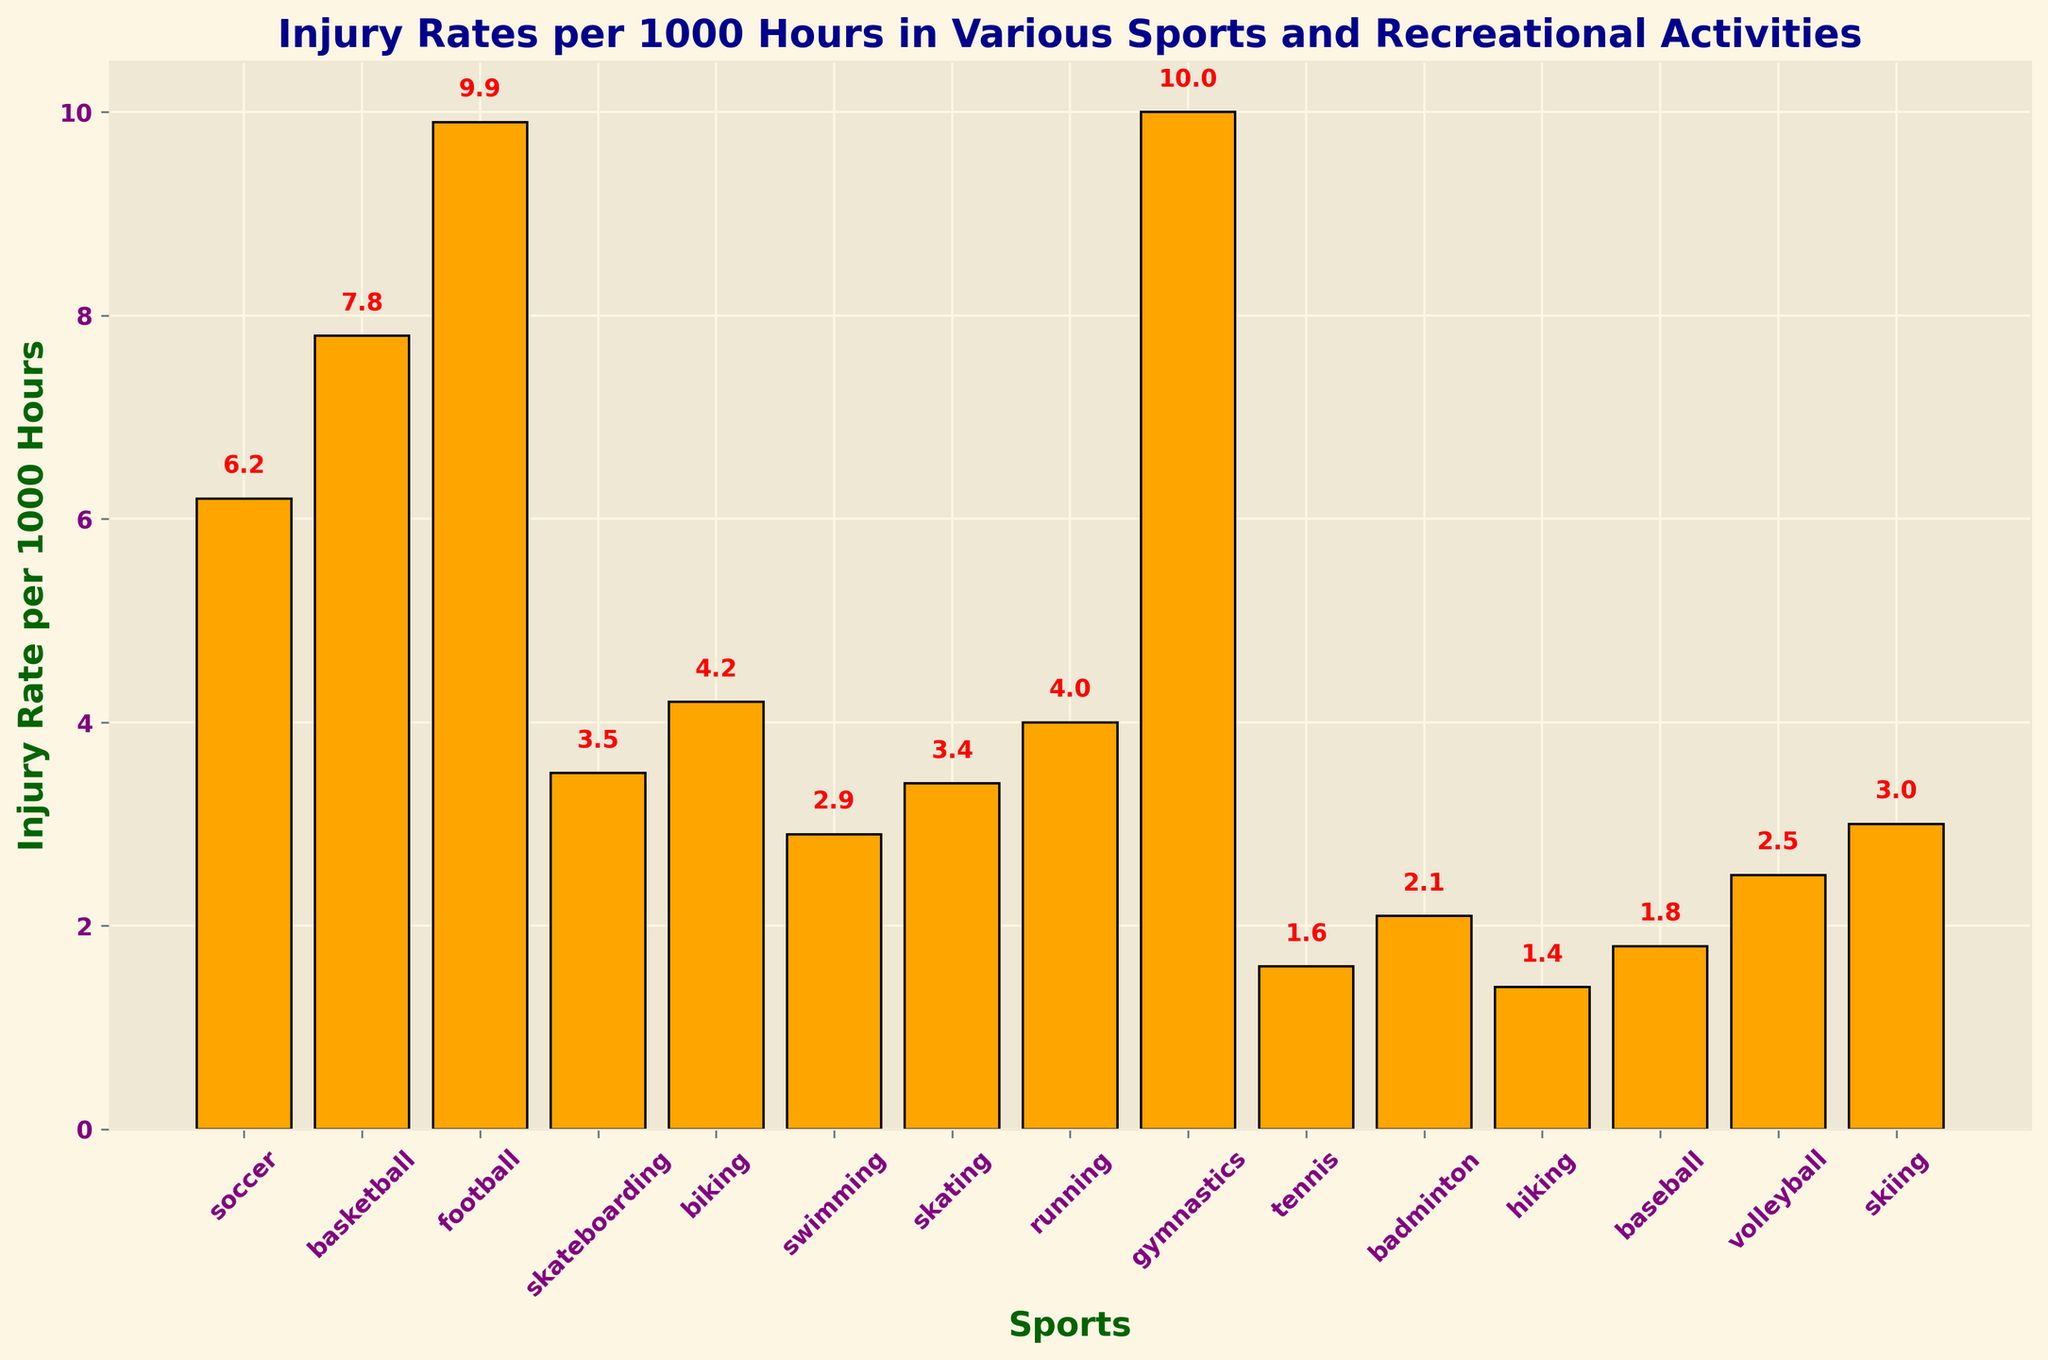Which sport has the highest injury rate? By looking at the height of the bars, gymnastics has the highest injury rate per 1000 hours, which is indicated by the tallest bar and the text label 10.0.
Answer: Gymnastics What is the injury rate of soccer compared to skateboarding? The bar for soccer is labeled 6.2 and the bar for skateboarding is labeled 3.5. Comparing these two values, soccer has a higher injury rate.
Answer: Soccer Which sports have an injury rate below 3? By reading the labels of the bars, swimming (2.9), tennis (1.6), badminton (2.1), hiking (1.4), baseball (1.8), and volleyball (2.5) have injury rates below 3.
Answer: Swimming, Tennis, Badminton, Hiking, Baseball, Volleyball What is the total injury rate for skating and skiing combined? The bar for skating shows an injury rate of 3.4 and the bar for skiing shows 3. To find the total, we sum these values: 3.4 + 3.0 = 6.4.
Answer: 6.4 Which sport has a lower injury rate, volleyball or biking? The bar for volleyball shows an injury rate of 2.5, while the bar for biking shows 4.2. Comparing these, volleyball has a lower injury rate.
Answer: Volleyball How much higher is the injury rate for football compared to tennis? The bar for football shows an injury rate of 9.9, and the bar for tennis shows 1.6. The difference is 9.9 - 1.6 = 8.3.
Answer: 8.3 What is the average injury rate across all the sports listed? First sum all injury rates: 6.2 + 7.8 + 9.9 + 3.5 + 4.2 + 2.9 + 3.4 + 4.0 + 10.0 + 1.6 + 2.1 + 1.4 + 1.8 + 2.5 + 3.0 = 64.3. There are 15 sports, so the average is 64.3 / 15 ≈ 4.29.
Answer: 4.29 What is the second highest injury rate among the listed sports? The highest injury rate is for gymnastics at 10.0. The second highest bar is for football at 9.9.
Answer: Football Which sport has an injury rate closest to 4? The bar for running has an injury rate of 4.0, which is closest to 4.
Answer: Running What is the difference in injury rates between biking and swimming? The bar for biking shows 4.2, and the bar for swimming shows 2.9. The difference is 4.2 - 2.9 = 1.3.
Answer: 1.3 